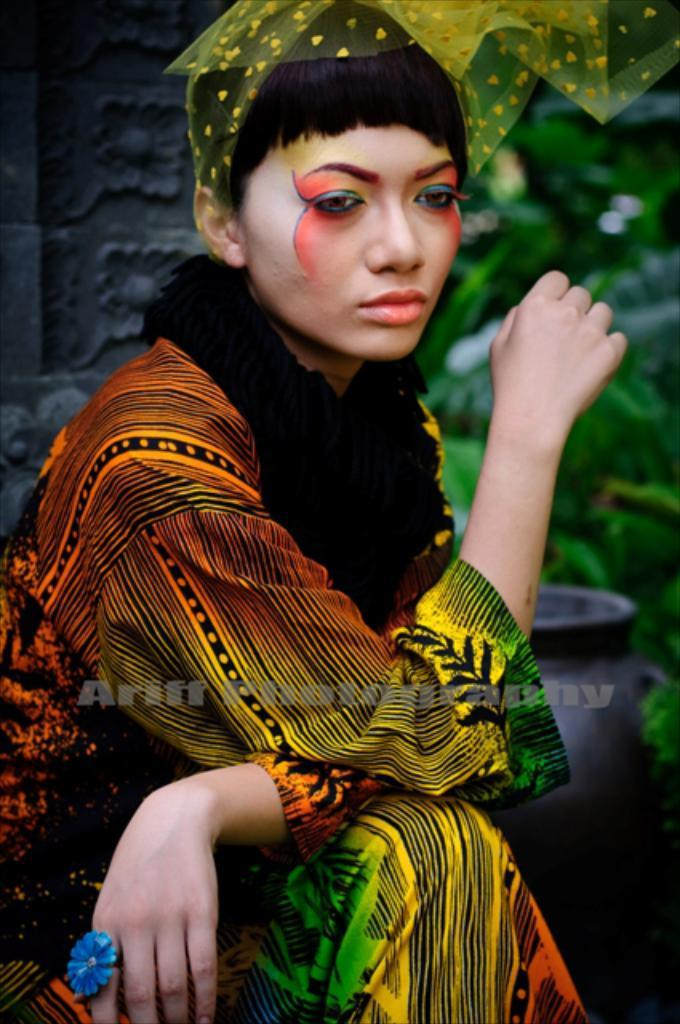What is the woman in the image doing? The woman is seated in the image. What is covering the woman's head? The woman has a cloth on her head. What can be seen on the right side of the image? There are plants on the right side of the image. What object is present in the image? There is a pot in the image. What architectural feature is visible on the left side of the image? There is a carved wall on the left side of the image. What type of yarn is being used to decorate the birthday cake in the image? There is no birthday cake or yarn present in the image. 